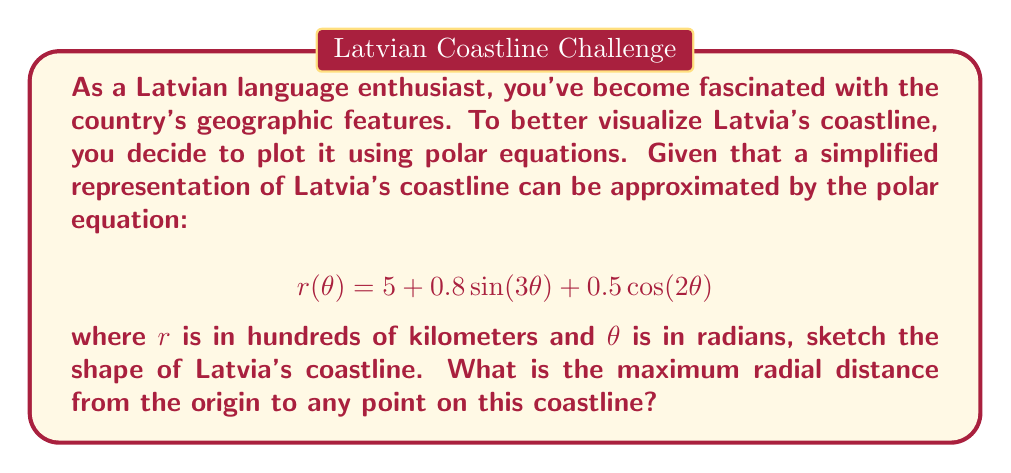Give your solution to this math problem. To solve this problem, we need to follow these steps:

1) First, let's understand what the equation represents. The polar equation $r(\theta) = 5 + 0.8\sin(3\theta) + 0.5\cos(2\theta)$ gives us the radial distance $r$ for any angle $\theta$.

2) To sketch the coastline, we would need to plot this equation for $\theta$ from 0 to $2\pi$. However, since we're not required to actually draw it, let's focus on finding the maximum radial distance.

3) To find the maximum value of $r$, we need to consider the maximum possible values of the sine and cosine terms:

   - $\sin(3\theta)$ has a maximum value of 1
   - $\cos(2\theta)$ has a maximum value of 1

4) Therefore, the maximum possible value of $r$ would occur when both these terms are at their maximum:

   $$r_{max} = 5 + 0.8(1) + 0.5(1)$$

5) Let's calculate this:

   $$r_{max} = 5 + 0.8 + 0.5 = 6.3$$

6) Remember that $r$ is in hundreds of kilometers. So the maximum radial distance is 630 km.

[asy]
import graph;
size(200);
real r(real t) {return 5 + 0.8*sin(3t) + 0.5*cos(2t);}
polargraph(r,0,2pi,operator ..);
draw(circle((0,0),6.3),dashed+red);
label("630 km",(3,2),NE);
[/asy]

The red dashed circle in the diagram represents the maximum radial distance.
Answer: The maximum radial distance from the origin to any point on the simplified representation of Latvia's coastline is 630 km. 